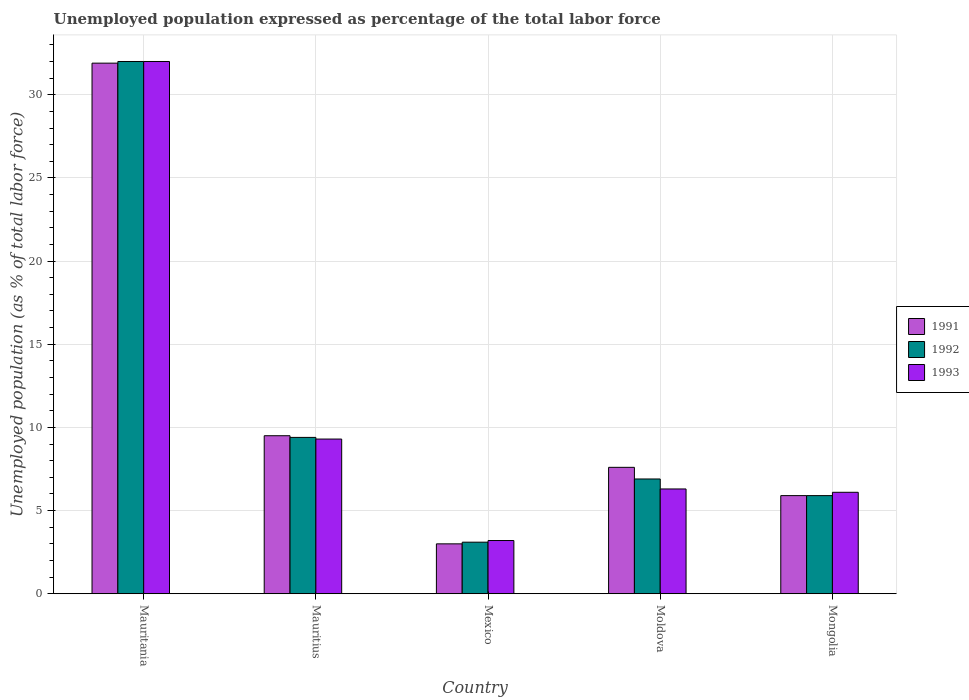How many different coloured bars are there?
Make the answer very short. 3. Are the number of bars per tick equal to the number of legend labels?
Ensure brevity in your answer.  Yes. Are the number of bars on each tick of the X-axis equal?
Offer a very short reply. Yes. What is the label of the 2nd group of bars from the left?
Your answer should be compact. Mauritius. What is the unemployment in in 1992 in Mauritania?
Your response must be concise. 32. Across all countries, what is the minimum unemployment in in 1991?
Your answer should be compact. 3. In which country was the unemployment in in 1993 maximum?
Provide a succinct answer. Mauritania. In which country was the unemployment in in 1992 minimum?
Ensure brevity in your answer.  Mexico. What is the total unemployment in in 1993 in the graph?
Your answer should be compact. 56.9. What is the difference between the unemployment in in 1993 in Mauritania and that in Moldova?
Make the answer very short. 25.7. What is the difference between the unemployment in in 1992 in Mexico and the unemployment in in 1993 in Mongolia?
Keep it short and to the point. -3. What is the average unemployment in in 1992 per country?
Keep it short and to the point. 11.46. What is the difference between the unemployment in of/in 1993 and unemployment in of/in 1992 in Moldova?
Give a very brief answer. -0.6. What is the ratio of the unemployment in in 1991 in Mauritania to that in Mexico?
Your answer should be very brief. 10.63. What is the difference between the highest and the second highest unemployment in in 1993?
Make the answer very short. 22.7. What is the difference between the highest and the lowest unemployment in in 1991?
Provide a short and direct response. 28.9. What does the 1st bar from the right in Mauritius represents?
Make the answer very short. 1993. How many bars are there?
Your answer should be very brief. 15. What is the difference between two consecutive major ticks on the Y-axis?
Offer a terse response. 5. Does the graph contain any zero values?
Your answer should be compact. No. Does the graph contain grids?
Provide a succinct answer. Yes. How are the legend labels stacked?
Provide a short and direct response. Vertical. What is the title of the graph?
Provide a short and direct response. Unemployed population expressed as percentage of the total labor force. What is the label or title of the Y-axis?
Offer a very short reply. Unemployed population (as % of total labor force). What is the Unemployed population (as % of total labor force) in 1991 in Mauritania?
Your answer should be very brief. 31.9. What is the Unemployed population (as % of total labor force) in 1992 in Mauritania?
Offer a very short reply. 32. What is the Unemployed population (as % of total labor force) in 1993 in Mauritania?
Provide a short and direct response. 32. What is the Unemployed population (as % of total labor force) of 1991 in Mauritius?
Offer a terse response. 9.5. What is the Unemployed population (as % of total labor force) in 1992 in Mauritius?
Ensure brevity in your answer.  9.4. What is the Unemployed population (as % of total labor force) of 1993 in Mauritius?
Provide a short and direct response. 9.3. What is the Unemployed population (as % of total labor force) in 1992 in Mexico?
Keep it short and to the point. 3.1. What is the Unemployed population (as % of total labor force) in 1993 in Mexico?
Your answer should be compact. 3.2. What is the Unemployed population (as % of total labor force) in 1991 in Moldova?
Keep it short and to the point. 7.6. What is the Unemployed population (as % of total labor force) in 1992 in Moldova?
Give a very brief answer. 6.9. What is the Unemployed population (as % of total labor force) in 1993 in Moldova?
Give a very brief answer. 6.3. What is the Unemployed population (as % of total labor force) in 1991 in Mongolia?
Your answer should be compact. 5.9. What is the Unemployed population (as % of total labor force) of 1992 in Mongolia?
Your answer should be compact. 5.9. What is the Unemployed population (as % of total labor force) in 1993 in Mongolia?
Provide a short and direct response. 6.1. Across all countries, what is the maximum Unemployed population (as % of total labor force) in 1991?
Make the answer very short. 31.9. Across all countries, what is the maximum Unemployed population (as % of total labor force) in 1992?
Provide a succinct answer. 32. Across all countries, what is the minimum Unemployed population (as % of total labor force) in 1992?
Make the answer very short. 3.1. Across all countries, what is the minimum Unemployed population (as % of total labor force) in 1993?
Ensure brevity in your answer.  3.2. What is the total Unemployed population (as % of total labor force) in 1991 in the graph?
Your response must be concise. 57.9. What is the total Unemployed population (as % of total labor force) in 1992 in the graph?
Offer a very short reply. 57.3. What is the total Unemployed population (as % of total labor force) of 1993 in the graph?
Provide a short and direct response. 56.9. What is the difference between the Unemployed population (as % of total labor force) in 1991 in Mauritania and that in Mauritius?
Your response must be concise. 22.4. What is the difference between the Unemployed population (as % of total labor force) of 1992 in Mauritania and that in Mauritius?
Provide a succinct answer. 22.6. What is the difference between the Unemployed population (as % of total labor force) in 1993 in Mauritania and that in Mauritius?
Your answer should be compact. 22.7. What is the difference between the Unemployed population (as % of total labor force) in 1991 in Mauritania and that in Mexico?
Offer a very short reply. 28.9. What is the difference between the Unemployed population (as % of total labor force) in 1992 in Mauritania and that in Mexico?
Your answer should be compact. 28.9. What is the difference between the Unemployed population (as % of total labor force) in 1993 in Mauritania and that in Mexico?
Make the answer very short. 28.8. What is the difference between the Unemployed population (as % of total labor force) in 1991 in Mauritania and that in Moldova?
Keep it short and to the point. 24.3. What is the difference between the Unemployed population (as % of total labor force) in 1992 in Mauritania and that in Moldova?
Give a very brief answer. 25.1. What is the difference between the Unemployed population (as % of total labor force) in 1993 in Mauritania and that in Moldova?
Ensure brevity in your answer.  25.7. What is the difference between the Unemployed population (as % of total labor force) of 1991 in Mauritania and that in Mongolia?
Give a very brief answer. 26. What is the difference between the Unemployed population (as % of total labor force) in 1992 in Mauritania and that in Mongolia?
Ensure brevity in your answer.  26.1. What is the difference between the Unemployed population (as % of total labor force) of 1993 in Mauritania and that in Mongolia?
Provide a succinct answer. 25.9. What is the difference between the Unemployed population (as % of total labor force) of 1991 in Mauritius and that in Mexico?
Provide a short and direct response. 6.5. What is the difference between the Unemployed population (as % of total labor force) in 1992 in Mauritius and that in Mexico?
Your response must be concise. 6.3. What is the difference between the Unemployed population (as % of total labor force) in 1993 in Mauritius and that in Moldova?
Your answer should be compact. 3. What is the difference between the Unemployed population (as % of total labor force) of 1991 in Mauritius and that in Mongolia?
Your response must be concise. 3.6. What is the difference between the Unemployed population (as % of total labor force) of 1993 in Mauritius and that in Mongolia?
Your response must be concise. 3.2. What is the difference between the Unemployed population (as % of total labor force) in 1992 in Mexico and that in Moldova?
Provide a short and direct response. -3.8. What is the difference between the Unemployed population (as % of total labor force) in 1991 in Moldova and that in Mongolia?
Your answer should be very brief. 1.7. What is the difference between the Unemployed population (as % of total labor force) in 1992 in Moldova and that in Mongolia?
Provide a succinct answer. 1. What is the difference between the Unemployed population (as % of total labor force) in 1993 in Moldova and that in Mongolia?
Ensure brevity in your answer.  0.2. What is the difference between the Unemployed population (as % of total labor force) of 1991 in Mauritania and the Unemployed population (as % of total labor force) of 1992 in Mauritius?
Offer a very short reply. 22.5. What is the difference between the Unemployed population (as % of total labor force) of 1991 in Mauritania and the Unemployed population (as % of total labor force) of 1993 in Mauritius?
Provide a succinct answer. 22.6. What is the difference between the Unemployed population (as % of total labor force) of 1992 in Mauritania and the Unemployed population (as % of total labor force) of 1993 in Mauritius?
Offer a terse response. 22.7. What is the difference between the Unemployed population (as % of total labor force) in 1991 in Mauritania and the Unemployed population (as % of total labor force) in 1992 in Mexico?
Your response must be concise. 28.8. What is the difference between the Unemployed population (as % of total labor force) in 1991 in Mauritania and the Unemployed population (as % of total labor force) in 1993 in Mexico?
Provide a succinct answer. 28.7. What is the difference between the Unemployed population (as % of total labor force) of 1992 in Mauritania and the Unemployed population (as % of total labor force) of 1993 in Mexico?
Your response must be concise. 28.8. What is the difference between the Unemployed population (as % of total labor force) in 1991 in Mauritania and the Unemployed population (as % of total labor force) in 1992 in Moldova?
Provide a short and direct response. 25. What is the difference between the Unemployed population (as % of total labor force) of 1991 in Mauritania and the Unemployed population (as % of total labor force) of 1993 in Moldova?
Make the answer very short. 25.6. What is the difference between the Unemployed population (as % of total labor force) of 1992 in Mauritania and the Unemployed population (as % of total labor force) of 1993 in Moldova?
Make the answer very short. 25.7. What is the difference between the Unemployed population (as % of total labor force) in 1991 in Mauritania and the Unemployed population (as % of total labor force) in 1992 in Mongolia?
Keep it short and to the point. 26. What is the difference between the Unemployed population (as % of total labor force) of 1991 in Mauritania and the Unemployed population (as % of total labor force) of 1993 in Mongolia?
Offer a terse response. 25.8. What is the difference between the Unemployed population (as % of total labor force) of 1992 in Mauritania and the Unemployed population (as % of total labor force) of 1993 in Mongolia?
Provide a succinct answer. 25.9. What is the difference between the Unemployed population (as % of total labor force) of 1991 in Mauritius and the Unemployed population (as % of total labor force) of 1993 in Mexico?
Ensure brevity in your answer.  6.3. What is the difference between the Unemployed population (as % of total labor force) in 1991 in Mauritius and the Unemployed population (as % of total labor force) in 1992 in Moldova?
Ensure brevity in your answer.  2.6. What is the difference between the Unemployed population (as % of total labor force) of 1991 in Mauritius and the Unemployed population (as % of total labor force) of 1993 in Moldova?
Give a very brief answer. 3.2. What is the difference between the Unemployed population (as % of total labor force) of 1991 in Mauritius and the Unemployed population (as % of total labor force) of 1993 in Mongolia?
Your answer should be compact. 3.4. What is the difference between the Unemployed population (as % of total labor force) in 1991 in Mexico and the Unemployed population (as % of total labor force) in 1993 in Moldova?
Keep it short and to the point. -3.3. What is the difference between the Unemployed population (as % of total labor force) in 1991 in Mexico and the Unemployed population (as % of total labor force) in 1992 in Mongolia?
Your answer should be compact. -2.9. What is the difference between the Unemployed population (as % of total labor force) of 1992 in Mexico and the Unemployed population (as % of total labor force) of 1993 in Mongolia?
Give a very brief answer. -3. What is the difference between the Unemployed population (as % of total labor force) of 1991 in Moldova and the Unemployed population (as % of total labor force) of 1992 in Mongolia?
Your answer should be compact. 1.7. What is the difference between the Unemployed population (as % of total labor force) in 1991 in Moldova and the Unemployed population (as % of total labor force) in 1993 in Mongolia?
Keep it short and to the point. 1.5. What is the difference between the Unemployed population (as % of total labor force) of 1992 in Moldova and the Unemployed population (as % of total labor force) of 1993 in Mongolia?
Offer a very short reply. 0.8. What is the average Unemployed population (as % of total labor force) of 1991 per country?
Provide a short and direct response. 11.58. What is the average Unemployed population (as % of total labor force) in 1992 per country?
Your answer should be very brief. 11.46. What is the average Unemployed population (as % of total labor force) of 1993 per country?
Your answer should be very brief. 11.38. What is the difference between the Unemployed population (as % of total labor force) of 1991 and Unemployed population (as % of total labor force) of 1992 in Mauritania?
Offer a terse response. -0.1. What is the difference between the Unemployed population (as % of total labor force) of 1991 and Unemployed population (as % of total labor force) of 1993 in Mauritania?
Your answer should be compact. -0.1. What is the difference between the Unemployed population (as % of total labor force) in 1991 and Unemployed population (as % of total labor force) in 1992 in Mauritius?
Ensure brevity in your answer.  0.1. What is the difference between the Unemployed population (as % of total labor force) of 1991 and Unemployed population (as % of total labor force) of 1992 in Mexico?
Provide a succinct answer. -0.1. What is the difference between the Unemployed population (as % of total labor force) in 1992 and Unemployed population (as % of total labor force) in 1993 in Mexico?
Provide a succinct answer. -0.1. What is the difference between the Unemployed population (as % of total labor force) in 1991 and Unemployed population (as % of total labor force) in 1993 in Moldova?
Provide a succinct answer. 1.3. What is the difference between the Unemployed population (as % of total labor force) of 1991 and Unemployed population (as % of total labor force) of 1992 in Mongolia?
Offer a terse response. 0. What is the ratio of the Unemployed population (as % of total labor force) in 1991 in Mauritania to that in Mauritius?
Your answer should be compact. 3.36. What is the ratio of the Unemployed population (as % of total labor force) of 1992 in Mauritania to that in Mauritius?
Give a very brief answer. 3.4. What is the ratio of the Unemployed population (as % of total labor force) of 1993 in Mauritania to that in Mauritius?
Your answer should be very brief. 3.44. What is the ratio of the Unemployed population (as % of total labor force) in 1991 in Mauritania to that in Mexico?
Offer a terse response. 10.63. What is the ratio of the Unemployed population (as % of total labor force) in 1992 in Mauritania to that in Mexico?
Keep it short and to the point. 10.32. What is the ratio of the Unemployed population (as % of total labor force) of 1993 in Mauritania to that in Mexico?
Offer a terse response. 10. What is the ratio of the Unemployed population (as % of total labor force) in 1991 in Mauritania to that in Moldova?
Offer a terse response. 4.2. What is the ratio of the Unemployed population (as % of total labor force) of 1992 in Mauritania to that in Moldova?
Your answer should be compact. 4.64. What is the ratio of the Unemployed population (as % of total labor force) of 1993 in Mauritania to that in Moldova?
Provide a succinct answer. 5.08. What is the ratio of the Unemployed population (as % of total labor force) in 1991 in Mauritania to that in Mongolia?
Your answer should be very brief. 5.41. What is the ratio of the Unemployed population (as % of total labor force) of 1992 in Mauritania to that in Mongolia?
Provide a succinct answer. 5.42. What is the ratio of the Unemployed population (as % of total labor force) in 1993 in Mauritania to that in Mongolia?
Offer a terse response. 5.25. What is the ratio of the Unemployed population (as % of total labor force) of 1991 in Mauritius to that in Mexico?
Your response must be concise. 3.17. What is the ratio of the Unemployed population (as % of total labor force) in 1992 in Mauritius to that in Mexico?
Give a very brief answer. 3.03. What is the ratio of the Unemployed population (as % of total labor force) of 1993 in Mauritius to that in Mexico?
Your response must be concise. 2.91. What is the ratio of the Unemployed population (as % of total labor force) of 1992 in Mauritius to that in Moldova?
Provide a succinct answer. 1.36. What is the ratio of the Unemployed population (as % of total labor force) in 1993 in Mauritius to that in Moldova?
Make the answer very short. 1.48. What is the ratio of the Unemployed population (as % of total labor force) of 1991 in Mauritius to that in Mongolia?
Make the answer very short. 1.61. What is the ratio of the Unemployed population (as % of total labor force) in 1992 in Mauritius to that in Mongolia?
Keep it short and to the point. 1.59. What is the ratio of the Unemployed population (as % of total labor force) in 1993 in Mauritius to that in Mongolia?
Give a very brief answer. 1.52. What is the ratio of the Unemployed population (as % of total labor force) of 1991 in Mexico to that in Moldova?
Your answer should be compact. 0.39. What is the ratio of the Unemployed population (as % of total labor force) in 1992 in Mexico to that in Moldova?
Offer a very short reply. 0.45. What is the ratio of the Unemployed population (as % of total labor force) of 1993 in Mexico to that in Moldova?
Make the answer very short. 0.51. What is the ratio of the Unemployed population (as % of total labor force) of 1991 in Mexico to that in Mongolia?
Offer a very short reply. 0.51. What is the ratio of the Unemployed population (as % of total labor force) in 1992 in Mexico to that in Mongolia?
Offer a terse response. 0.53. What is the ratio of the Unemployed population (as % of total labor force) of 1993 in Mexico to that in Mongolia?
Provide a short and direct response. 0.52. What is the ratio of the Unemployed population (as % of total labor force) in 1991 in Moldova to that in Mongolia?
Keep it short and to the point. 1.29. What is the ratio of the Unemployed population (as % of total labor force) of 1992 in Moldova to that in Mongolia?
Keep it short and to the point. 1.17. What is the ratio of the Unemployed population (as % of total labor force) of 1993 in Moldova to that in Mongolia?
Your response must be concise. 1.03. What is the difference between the highest and the second highest Unemployed population (as % of total labor force) in 1991?
Your answer should be compact. 22.4. What is the difference between the highest and the second highest Unemployed population (as % of total labor force) of 1992?
Make the answer very short. 22.6. What is the difference between the highest and the second highest Unemployed population (as % of total labor force) in 1993?
Provide a short and direct response. 22.7. What is the difference between the highest and the lowest Unemployed population (as % of total labor force) of 1991?
Provide a short and direct response. 28.9. What is the difference between the highest and the lowest Unemployed population (as % of total labor force) in 1992?
Your answer should be compact. 28.9. What is the difference between the highest and the lowest Unemployed population (as % of total labor force) in 1993?
Your answer should be compact. 28.8. 